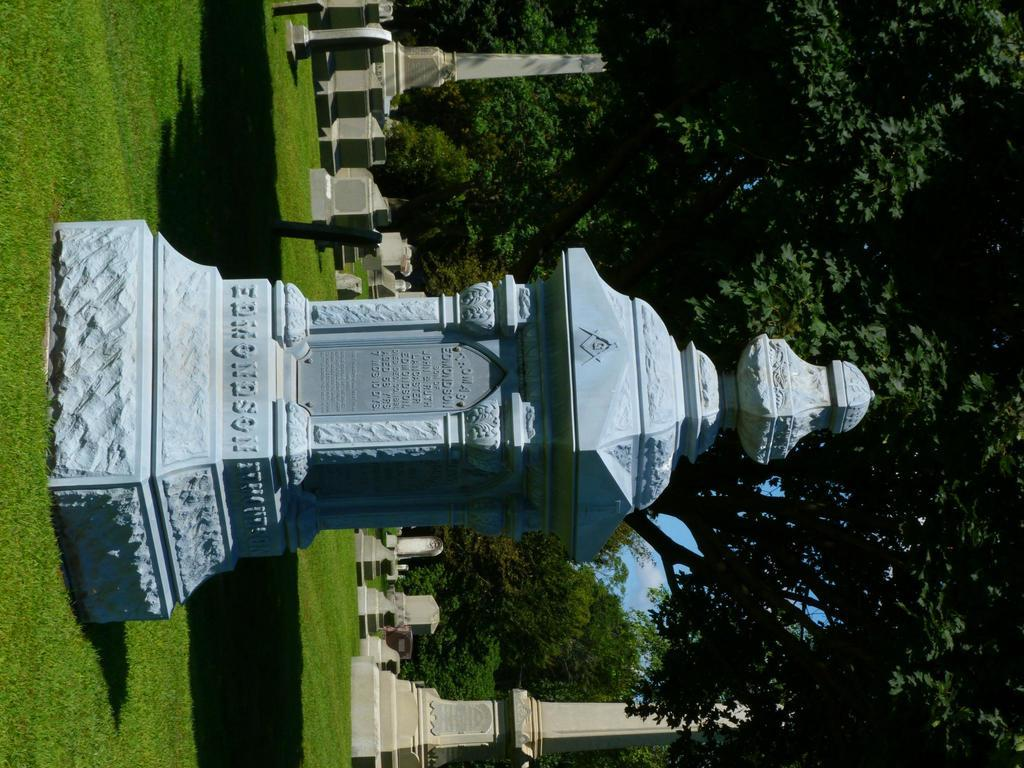What type of structure is present in the image? There is a memorial in the image. What can be found near the memorial? There are graves in the image. What type of vegetation is present in the image? There are trees in the image. What type of ground cover is present at the bottom of the image? There is grass at the bottom of the image. What type of nerve is present in the image? There is no nerve present in the image; it features a memorial, graves, trees, and grass. 